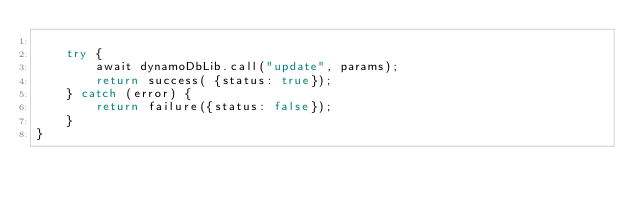Convert code to text. <code><loc_0><loc_0><loc_500><loc_500><_JavaScript_>
	try {
		await dynamoDbLib.call("update", params);
		return success( {status: true});
	} catch (error) {
		return failure({status: false});
	}
}</code> 